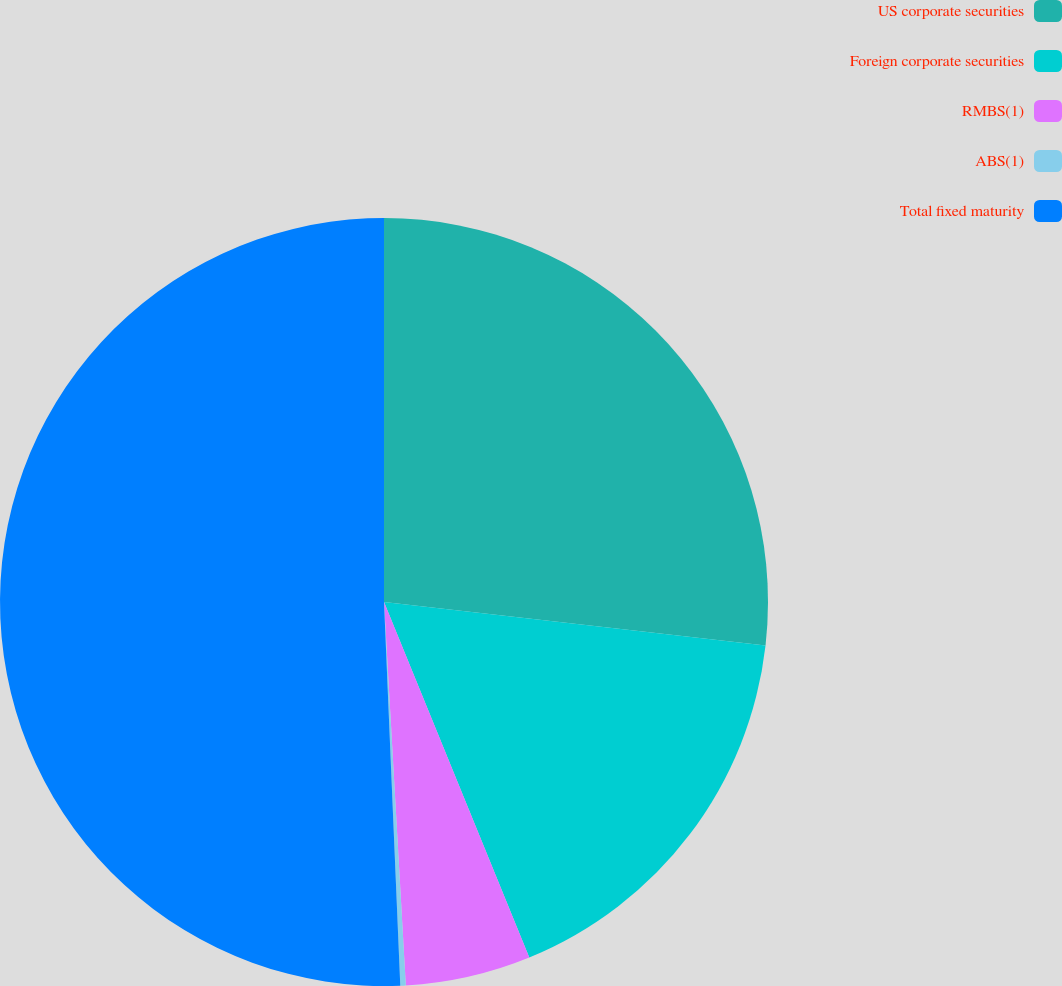Convert chart. <chart><loc_0><loc_0><loc_500><loc_500><pie_chart><fcel>US corporate securities<fcel>Foreign corporate securities<fcel>RMBS(1)<fcel>ABS(1)<fcel>Total fixed maturity<nl><fcel>26.8%<fcel>17.02%<fcel>5.27%<fcel>0.23%<fcel>50.67%<nl></chart> 